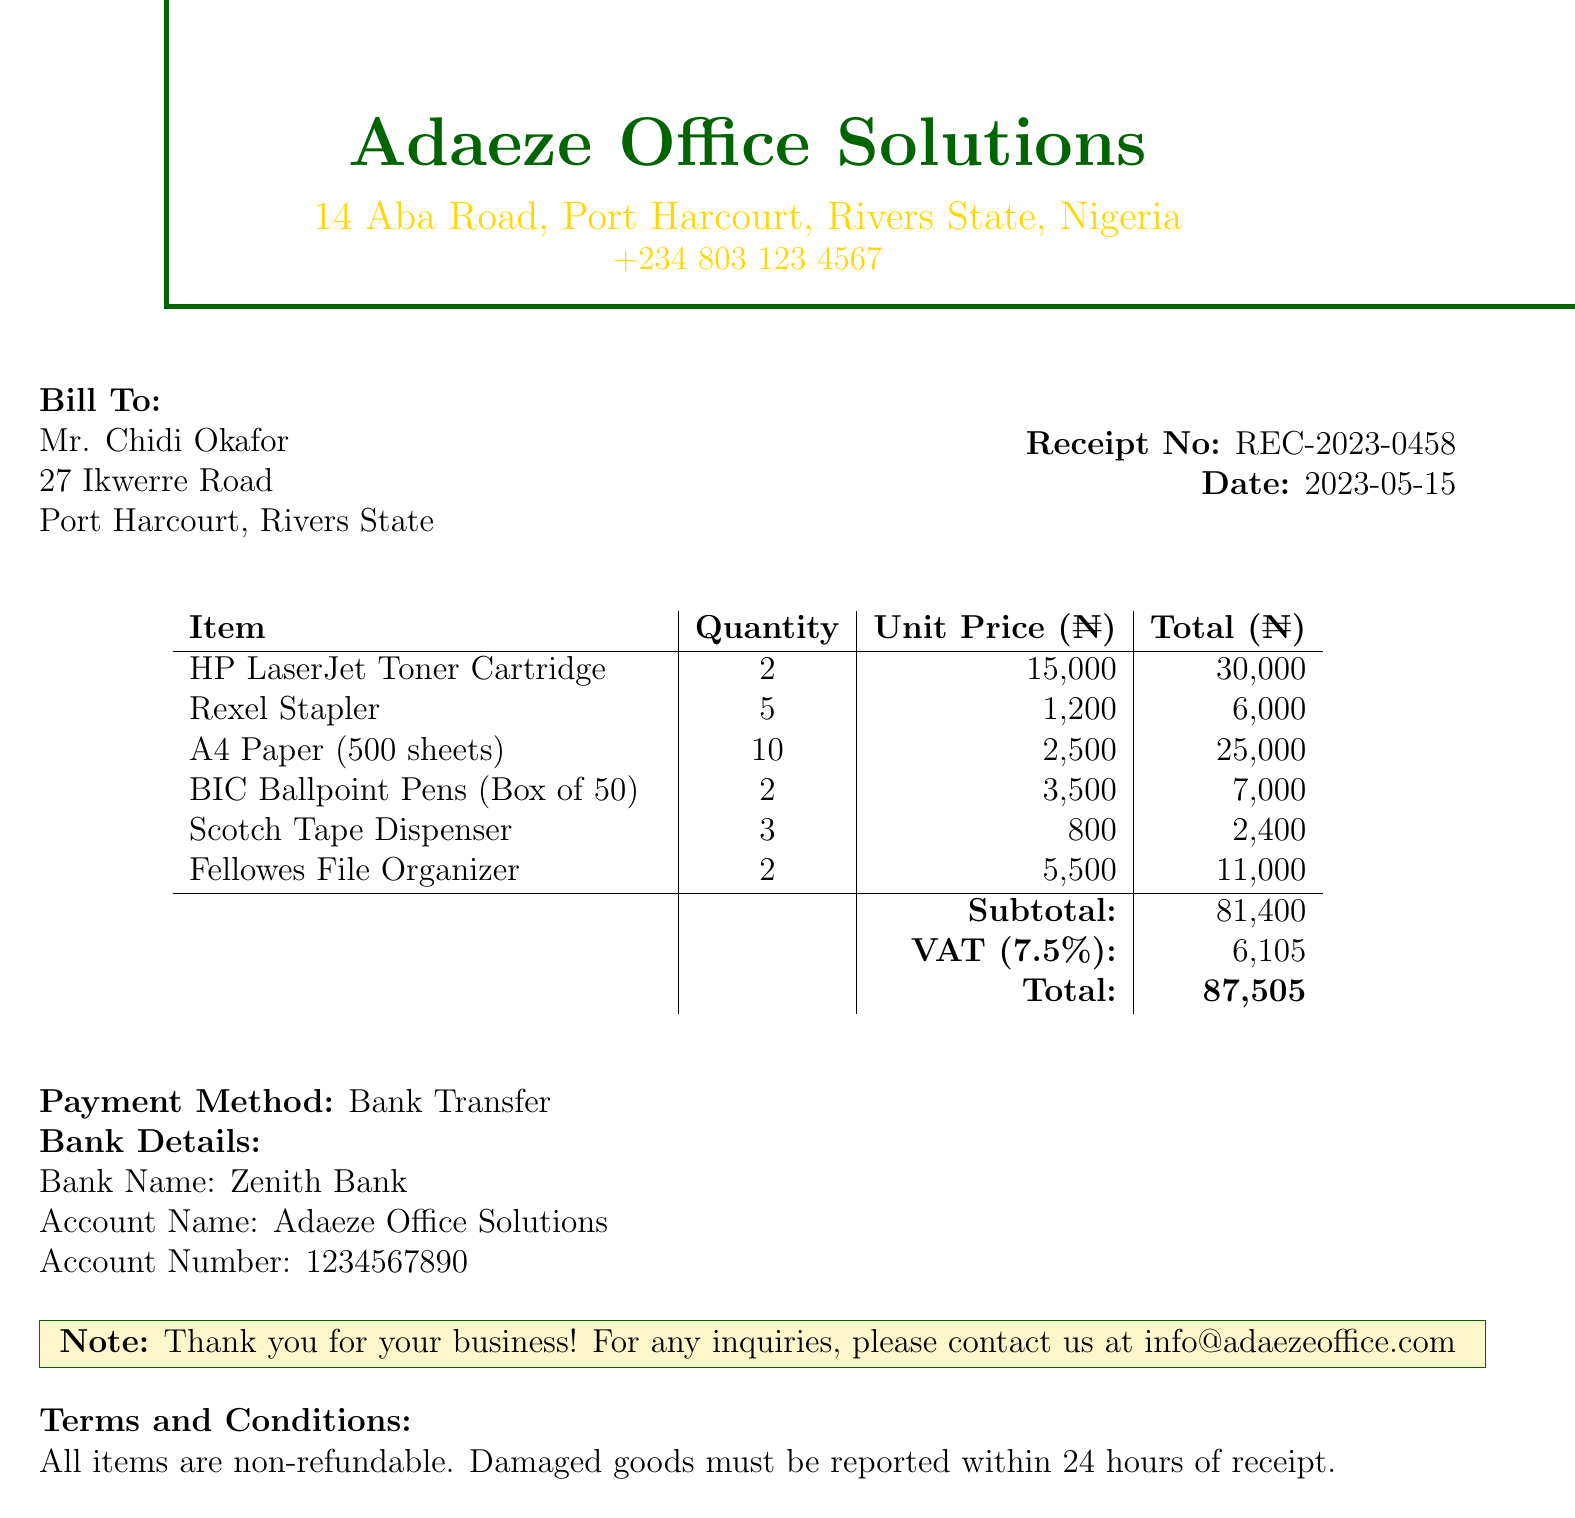What is the business name? The business name is prominently displayed at the top of the document.
Answer: Adaeze Office Solutions What is the receipt number? The receipt number is indicated in the top right corner of the document.
Answer: REC-2023-0458 What is the date of the transaction? The date is shown alongside the receipt number, indicating when the purchase was made.
Answer: 2023-05-15 Who is the customer? The customer's name is listed under "Bill To" section.
Answer: Mr. Chidi Okafor What is the total amount paid? The total amount is at the bottom of the itemized list prior to payment method details.
Answer: 87505 How many A4 Paper packs were purchased? The number of packs is included in the itemized list with quantities for each item.
Answer: 10 What is the VAT rate applied? The VAT rate is stated in the itemized list just before the total amount.
Answer: 7.5% How many items are non-refundable according to the terms? The terms and conditions specify the policy for all items sold.
Answer: All items What method was used to make the payment? The payment method is clearly stated before bank details.
Answer: Bank Transfer What is the account number for the business? The account number is listed under bank details at the end of the document.
Answer: 1234567890 